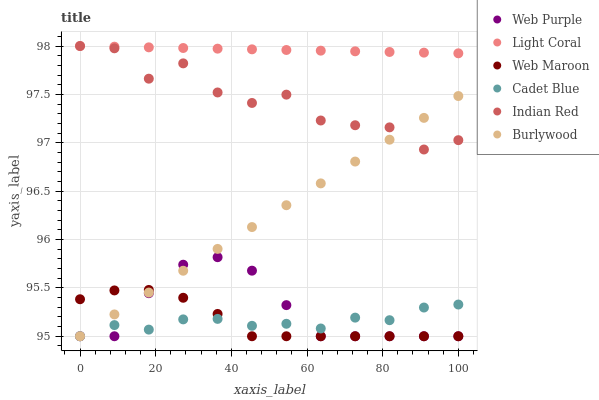Does Cadet Blue have the minimum area under the curve?
Answer yes or no. Yes. Does Light Coral have the maximum area under the curve?
Answer yes or no. Yes. Does Burlywood have the minimum area under the curve?
Answer yes or no. No. Does Burlywood have the maximum area under the curve?
Answer yes or no. No. Is Light Coral the smoothest?
Answer yes or no. Yes. Is Indian Red the roughest?
Answer yes or no. Yes. Is Burlywood the smoothest?
Answer yes or no. No. Is Burlywood the roughest?
Answer yes or no. No. Does Cadet Blue have the lowest value?
Answer yes or no. Yes. Does Light Coral have the lowest value?
Answer yes or no. No. Does Indian Red have the highest value?
Answer yes or no. Yes. Does Burlywood have the highest value?
Answer yes or no. No. Is Web Purple less than Indian Red?
Answer yes or no. Yes. Is Light Coral greater than Burlywood?
Answer yes or no. Yes. Does Cadet Blue intersect Web Maroon?
Answer yes or no. Yes. Is Cadet Blue less than Web Maroon?
Answer yes or no. No. Is Cadet Blue greater than Web Maroon?
Answer yes or no. No. Does Web Purple intersect Indian Red?
Answer yes or no. No. 